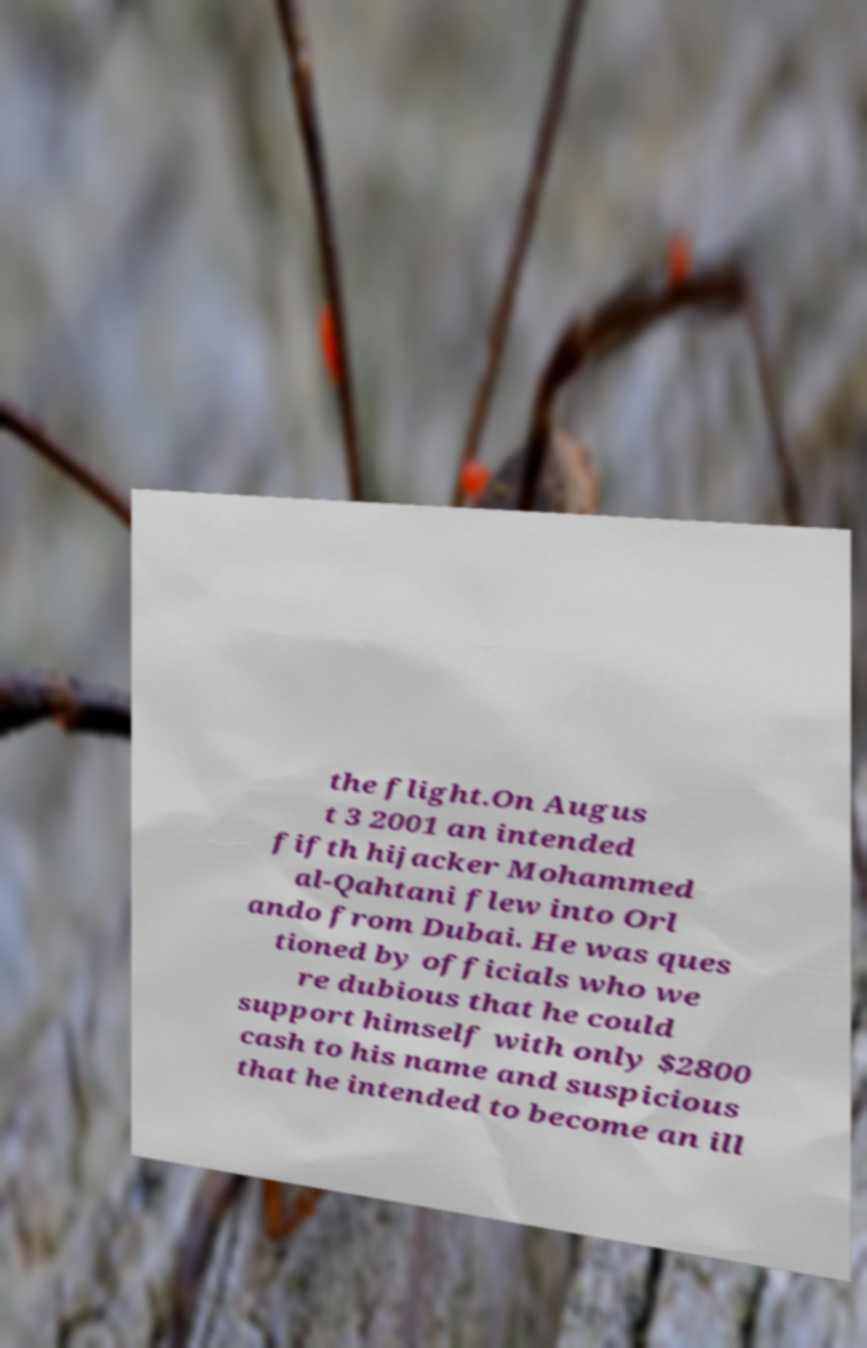There's text embedded in this image that I need extracted. Can you transcribe it verbatim? the flight.On Augus t 3 2001 an intended fifth hijacker Mohammed al-Qahtani flew into Orl ando from Dubai. He was ques tioned by officials who we re dubious that he could support himself with only $2800 cash to his name and suspicious that he intended to become an ill 